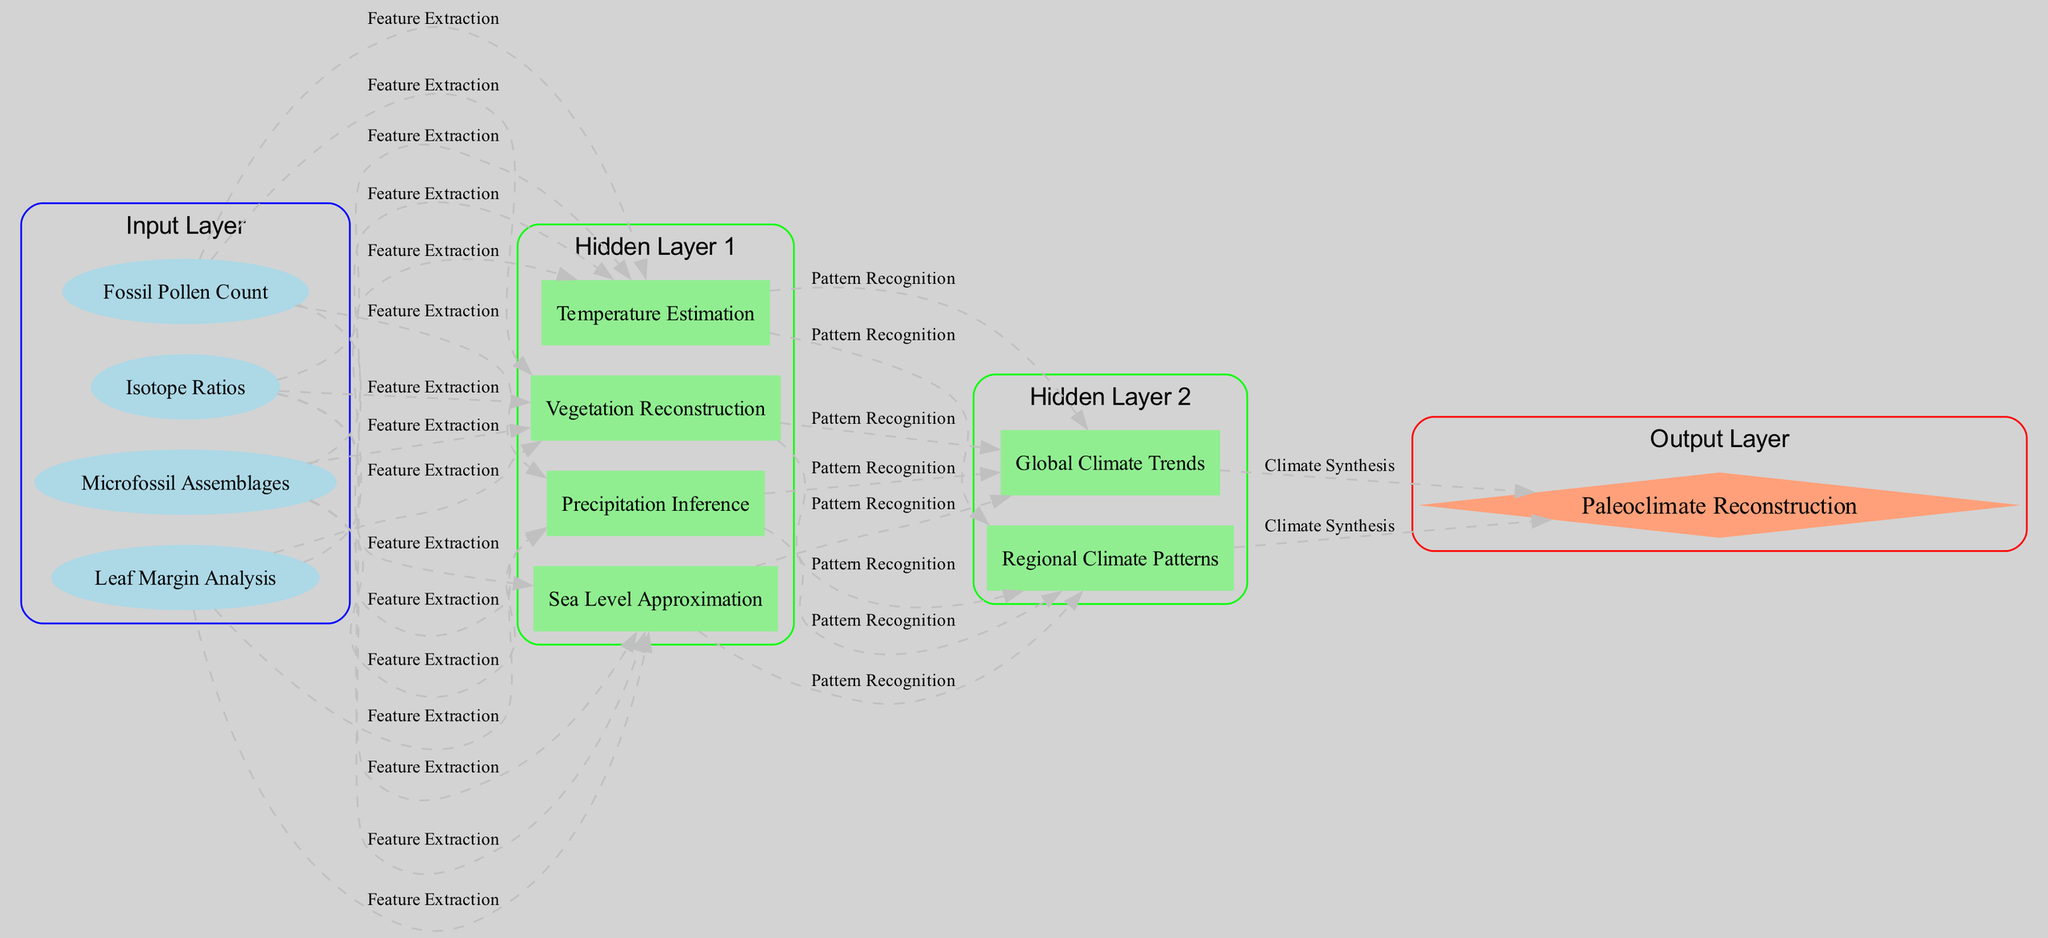What is the output of the neural network? The output layer contains one node labeled "Paleoclimate Reconstruction". This node represents the final result of the neural network after all processing.
Answer: Paleoclimate Reconstruction How many nodes are in the input layer? The input layer consists of four nodes: "Fossil Pollen Count", "Leaf Margin Analysis", "Isotope Ratios", and "Microfossil Assemblages". Thus, the total is four.
Answer: 4 What type of analysis is done between the input layer and the first hidden layer? The connection from the input layer to the first hidden layer is labeled "Feature Extraction". This describes the process through which useful features are derived from the input data.
Answer: Feature Extraction What is the label of the connection from the first hidden layer to the second hidden layer? The label of the connection from the first hidden layer to the second hidden layer is "Pattern Recognition". This indicates the type of processing happening between these two layers.
Answer: Pattern Recognition Which node in the first hidden layer estimates temperature? The node specifically responsible for estimating temperature in the first hidden layer is labeled "Temperature Estimation". This is one of the outputs processed in the hidden layer.
Answer: Temperature Estimation How many hidden layers are there in total? The structure shows there are two hidden layers: the first hidden layer contains four nodes and the second hidden layer contains two nodes. Therefore, the total is two hidden layers.
Answer: 2 What is the last connection label in the structure? The last connection from the second hidden layer to the output layer is labeled "Climate Synthesis". This denotes the final step before producing the output.
Answer: Climate Synthesis Which hidden node relates to global climate trends? The second hidden layer has a node labeled "Global Climate Trends", which specifically addresses broader climate patterns across the globe.
Answer: Global Climate Trends What is the purpose of the second hidden layer? The second hidden layer consists of nodes related to "Regional Climate Patterns" and "Global Climate Trends", focusing on synthesizing and recognizing larger scale climate relationships.
Answer: Regional Climate Patterns, Global Climate Trends 